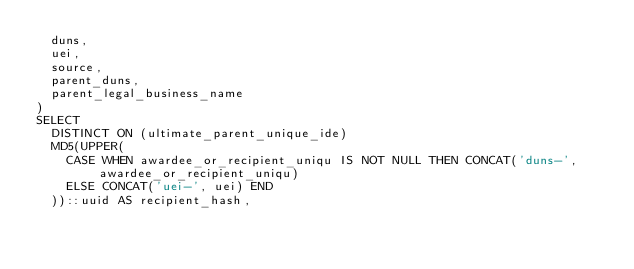<code> <loc_0><loc_0><loc_500><loc_500><_SQL_>  duns,
  uei,
  source,
  parent_duns,
  parent_legal_business_name
)
SELECT
  DISTINCT ON (ultimate_parent_unique_ide)
  MD5(UPPER(
    CASE WHEN awardee_or_recipient_uniqu IS NOT NULL THEN CONCAT('duns-', awardee_or_recipient_uniqu)
    ELSE CONCAT('uei-', uei) END
  ))::uuid AS recipient_hash,</code> 